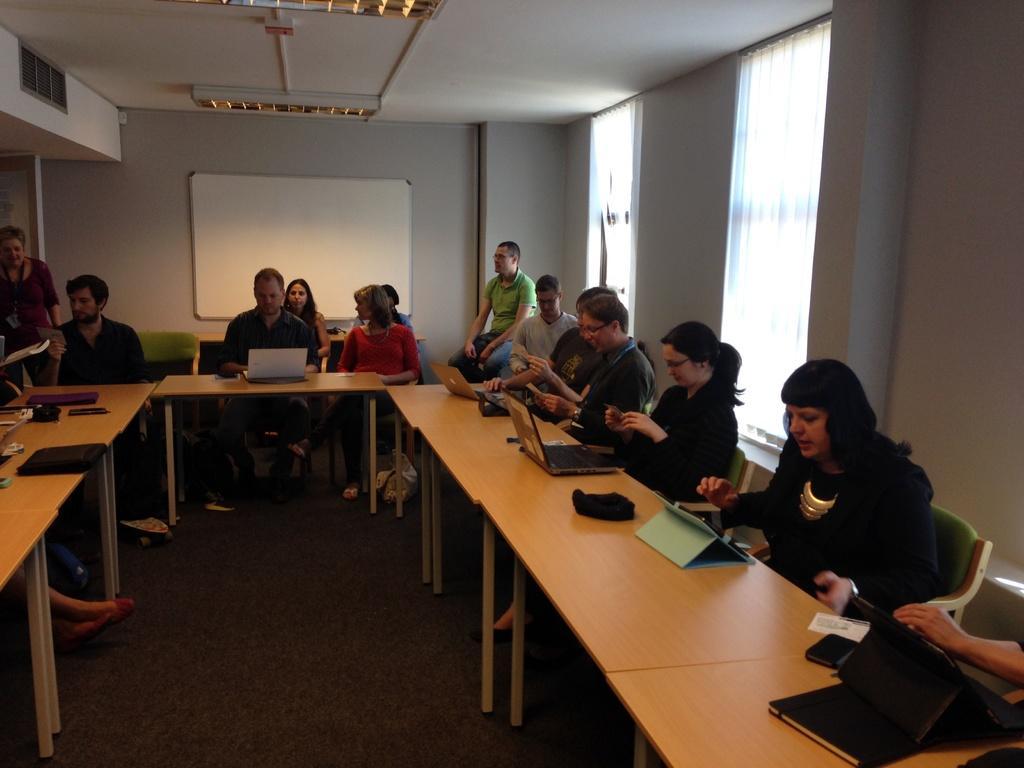Please provide a concise description of this image. In this image there are group of people sitting on the chair. In front of the people there is a table on table there is a laptop. At the background we can see a wall and a board. 